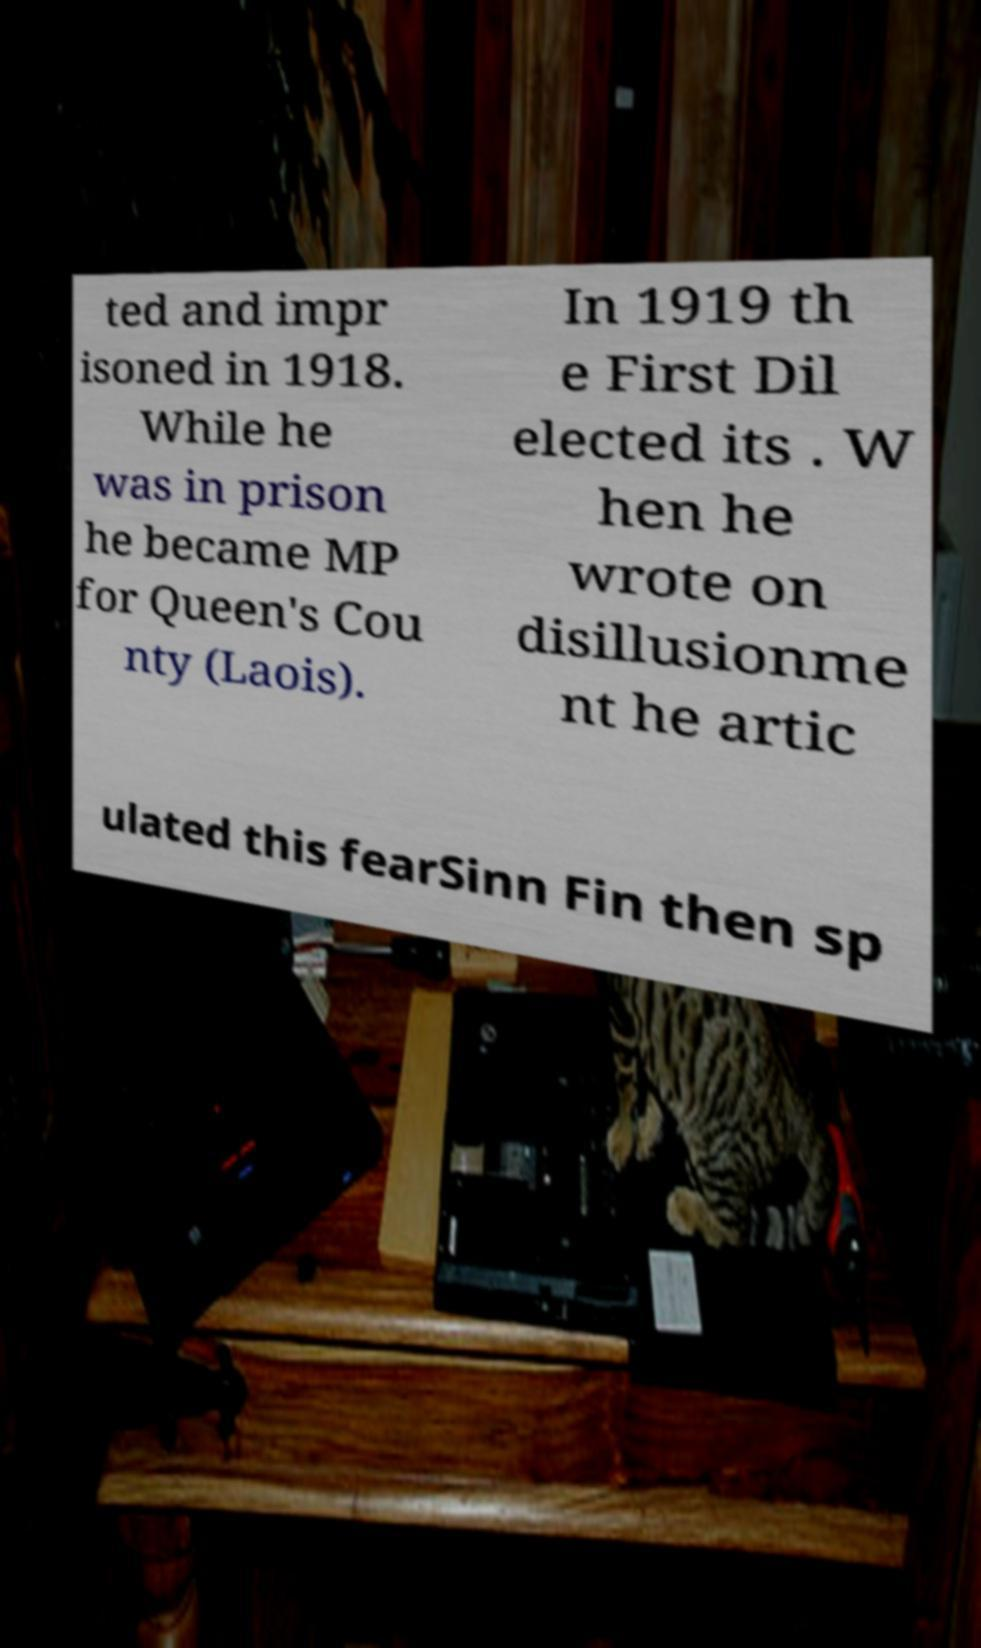Please identify and transcribe the text found in this image. ted and impr isoned in 1918. While he was in prison he became MP for Queen's Cou nty (Laois). In 1919 th e First Dil elected its . W hen he wrote on disillusionme nt he artic ulated this fearSinn Fin then sp 